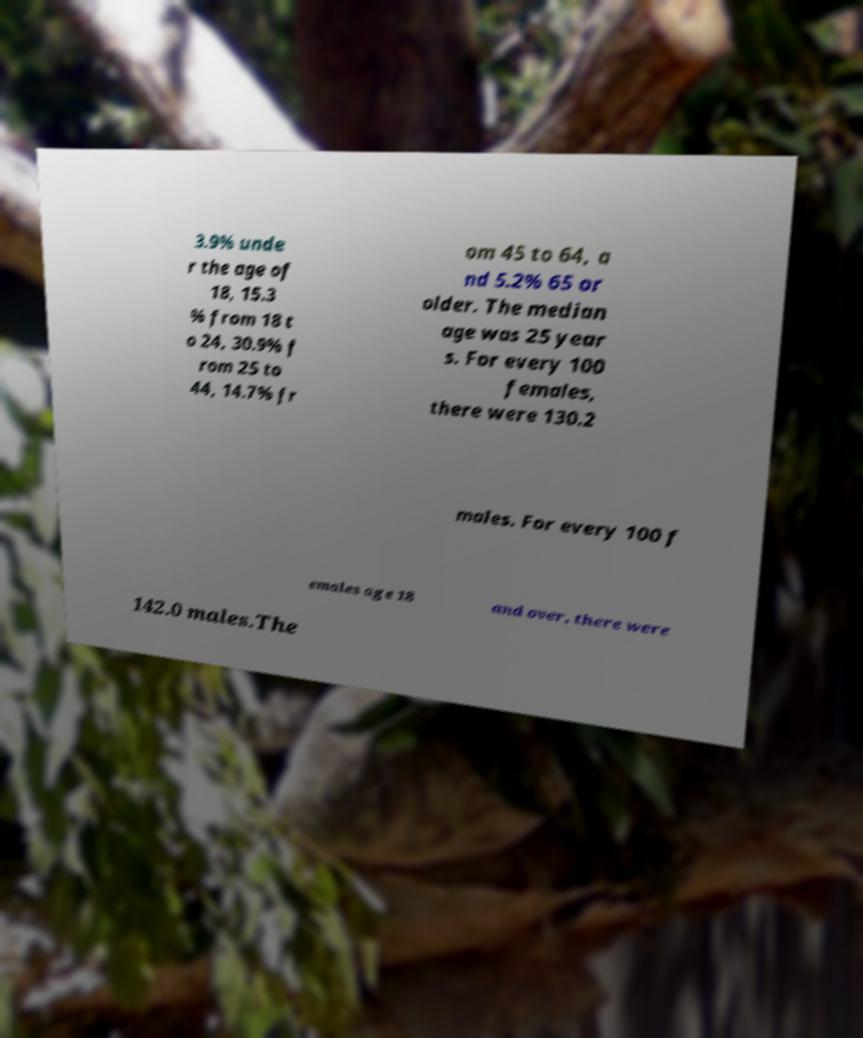Can you accurately transcribe the text from the provided image for me? 3.9% unde r the age of 18, 15.3 % from 18 t o 24, 30.9% f rom 25 to 44, 14.7% fr om 45 to 64, a nd 5.2% 65 or older. The median age was 25 year s. For every 100 females, there were 130.2 males. For every 100 f emales age 18 and over, there were 142.0 males.The 